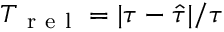Convert formula to latex. <formula><loc_0><loc_0><loc_500><loc_500>T _ { r e l } = | \tau - \hat { \tau } | / \tau</formula> 